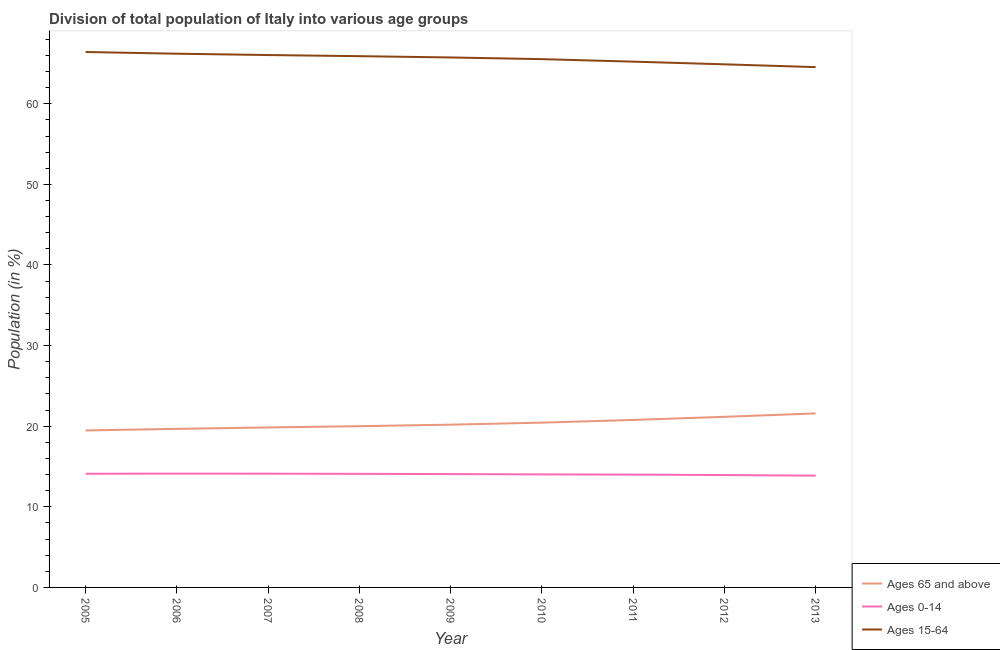How many different coloured lines are there?
Give a very brief answer. 3. Does the line corresponding to percentage of population within the age-group of 65 and above intersect with the line corresponding to percentage of population within the age-group 15-64?
Your answer should be very brief. No. Is the number of lines equal to the number of legend labels?
Keep it short and to the point. Yes. What is the percentage of population within the age-group 15-64 in 2009?
Keep it short and to the point. 65.75. Across all years, what is the maximum percentage of population within the age-group 0-14?
Your response must be concise. 14.12. Across all years, what is the minimum percentage of population within the age-group 15-64?
Offer a terse response. 64.55. What is the total percentage of population within the age-group of 65 and above in the graph?
Your answer should be very brief. 183.16. What is the difference between the percentage of population within the age-group 15-64 in 2005 and that in 2008?
Your response must be concise. 0.52. What is the difference between the percentage of population within the age-group 15-64 in 2013 and the percentage of population within the age-group 0-14 in 2009?
Provide a succinct answer. 50.49. What is the average percentage of population within the age-group 0-14 per year?
Ensure brevity in your answer.  14.03. In the year 2008, what is the difference between the percentage of population within the age-group of 65 and above and percentage of population within the age-group 0-14?
Ensure brevity in your answer.  5.92. In how many years, is the percentage of population within the age-group of 65 and above greater than 56 %?
Your response must be concise. 0. What is the ratio of the percentage of population within the age-group of 65 and above in 2007 to that in 2010?
Offer a very short reply. 0.97. Is the percentage of population within the age-group 15-64 in 2006 less than that in 2009?
Offer a very short reply. No. What is the difference between the highest and the second highest percentage of population within the age-group 15-64?
Your answer should be compact. 0.21. What is the difference between the highest and the lowest percentage of population within the age-group 0-14?
Your response must be concise. 0.25. In how many years, is the percentage of population within the age-group of 65 and above greater than the average percentage of population within the age-group of 65 and above taken over all years?
Give a very brief answer. 4. Is it the case that in every year, the sum of the percentage of population within the age-group of 65 and above and percentage of population within the age-group 0-14 is greater than the percentage of population within the age-group 15-64?
Your answer should be compact. No. Does the percentage of population within the age-group of 65 and above monotonically increase over the years?
Keep it short and to the point. Yes. How many lines are there?
Make the answer very short. 3. How many years are there in the graph?
Provide a short and direct response. 9. Are the values on the major ticks of Y-axis written in scientific E-notation?
Make the answer very short. No. How many legend labels are there?
Offer a very short reply. 3. How are the legend labels stacked?
Provide a short and direct response. Vertical. What is the title of the graph?
Make the answer very short. Division of total population of Italy into various age groups
. Does "Argument" appear as one of the legend labels in the graph?
Make the answer very short. No. What is the label or title of the X-axis?
Offer a very short reply. Year. What is the label or title of the Y-axis?
Keep it short and to the point. Population (in %). What is the Population (in %) in Ages 65 and above in 2005?
Offer a terse response. 19.47. What is the Population (in %) of Ages 0-14 in 2005?
Offer a very short reply. 14.11. What is the Population (in %) of Ages 15-64 in 2005?
Provide a short and direct response. 66.42. What is the Population (in %) in Ages 65 and above in 2006?
Make the answer very short. 19.67. What is the Population (in %) in Ages 0-14 in 2006?
Make the answer very short. 14.12. What is the Population (in %) in Ages 15-64 in 2006?
Your answer should be compact. 66.21. What is the Population (in %) in Ages 65 and above in 2007?
Give a very brief answer. 19.84. What is the Population (in %) of Ages 0-14 in 2007?
Provide a short and direct response. 14.11. What is the Population (in %) in Ages 15-64 in 2007?
Your answer should be very brief. 66.05. What is the Population (in %) of Ages 65 and above in 2008?
Your response must be concise. 20.01. What is the Population (in %) in Ages 0-14 in 2008?
Ensure brevity in your answer.  14.09. What is the Population (in %) in Ages 15-64 in 2008?
Provide a succinct answer. 65.91. What is the Population (in %) in Ages 65 and above in 2009?
Provide a succinct answer. 20.19. What is the Population (in %) in Ages 0-14 in 2009?
Offer a very short reply. 14.06. What is the Population (in %) in Ages 15-64 in 2009?
Offer a very short reply. 65.75. What is the Population (in %) in Ages 65 and above in 2010?
Offer a very short reply. 20.44. What is the Population (in %) in Ages 0-14 in 2010?
Your answer should be very brief. 14.02. What is the Population (in %) in Ages 15-64 in 2010?
Your response must be concise. 65.54. What is the Population (in %) in Ages 65 and above in 2011?
Your answer should be very brief. 20.78. What is the Population (in %) of Ages 0-14 in 2011?
Give a very brief answer. 14. What is the Population (in %) in Ages 15-64 in 2011?
Your answer should be very brief. 65.23. What is the Population (in %) in Ages 65 and above in 2012?
Your answer should be compact. 21.16. What is the Population (in %) of Ages 0-14 in 2012?
Your answer should be compact. 13.94. What is the Population (in %) of Ages 15-64 in 2012?
Offer a very short reply. 64.9. What is the Population (in %) in Ages 65 and above in 2013?
Provide a succinct answer. 21.59. What is the Population (in %) of Ages 0-14 in 2013?
Provide a succinct answer. 13.87. What is the Population (in %) of Ages 15-64 in 2013?
Give a very brief answer. 64.55. Across all years, what is the maximum Population (in %) of Ages 65 and above?
Your answer should be very brief. 21.59. Across all years, what is the maximum Population (in %) in Ages 0-14?
Offer a very short reply. 14.12. Across all years, what is the maximum Population (in %) of Ages 15-64?
Keep it short and to the point. 66.42. Across all years, what is the minimum Population (in %) of Ages 65 and above?
Make the answer very short. 19.47. Across all years, what is the minimum Population (in %) of Ages 0-14?
Offer a terse response. 13.87. Across all years, what is the minimum Population (in %) in Ages 15-64?
Offer a very short reply. 64.55. What is the total Population (in %) of Ages 65 and above in the graph?
Offer a terse response. 183.16. What is the total Population (in %) in Ages 0-14 in the graph?
Give a very brief answer. 126.3. What is the total Population (in %) of Ages 15-64 in the graph?
Provide a succinct answer. 590.54. What is the difference between the Population (in %) of Ages 65 and above in 2005 and that in 2006?
Offer a very short reply. -0.2. What is the difference between the Population (in %) of Ages 0-14 in 2005 and that in 2006?
Your response must be concise. -0.01. What is the difference between the Population (in %) in Ages 15-64 in 2005 and that in 2006?
Ensure brevity in your answer.  0.21. What is the difference between the Population (in %) of Ages 65 and above in 2005 and that in 2007?
Offer a terse response. -0.37. What is the difference between the Population (in %) of Ages 0-14 in 2005 and that in 2007?
Your answer should be compact. -0. What is the difference between the Population (in %) in Ages 15-64 in 2005 and that in 2007?
Provide a short and direct response. 0.38. What is the difference between the Population (in %) in Ages 65 and above in 2005 and that in 2008?
Offer a terse response. -0.53. What is the difference between the Population (in %) of Ages 0-14 in 2005 and that in 2008?
Provide a short and direct response. 0.02. What is the difference between the Population (in %) of Ages 15-64 in 2005 and that in 2008?
Ensure brevity in your answer.  0.52. What is the difference between the Population (in %) in Ages 65 and above in 2005 and that in 2009?
Give a very brief answer. -0.72. What is the difference between the Population (in %) of Ages 0-14 in 2005 and that in 2009?
Offer a terse response. 0.04. What is the difference between the Population (in %) in Ages 15-64 in 2005 and that in 2009?
Provide a succinct answer. 0.68. What is the difference between the Population (in %) in Ages 65 and above in 2005 and that in 2010?
Provide a succinct answer. -0.97. What is the difference between the Population (in %) in Ages 0-14 in 2005 and that in 2010?
Make the answer very short. 0.08. What is the difference between the Population (in %) of Ages 15-64 in 2005 and that in 2010?
Keep it short and to the point. 0.89. What is the difference between the Population (in %) of Ages 65 and above in 2005 and that in 2011?
Keep it short and to the point. -1.3. What is the difference between the Population (in %) in Ages 0-14 in 2005 and that in 2011?
Ensure brevity in your answer.  0.11. What is the difference between the Population (in %) of Ages 15-64 in 2005 and that in 2011?
Provide a short and direct response. 1.19. What is the difference between the Population (in %) in Ages 65 and above in 2005 and that in 2012?
Make the answer very short. -1.69. What is the difference between the Population (in %) in Ages 0-14 in 2005 and that in 2012?
Provide a short and direct response. 0.16. What is the difference between the Population (in %) in Ages 15-64 in 2005 and that in 2012?
Provide a short and direct response. 1.53. What is the difference between the Population (in %) of Ages 65 and above in 2005 and that in 2013?
Keep it short and to the point. -2.12. What is the difference between the Population (in %) in Ages 0-14 in 2005 and that in 2013?
Your answer should be very brief. 0.24. What is the difference between the Population (in %) of Ages 15-64 in 2005 and that in 2013?
Provide a succinct answer. 1.88. What is the difference between the Population (in %) in Ages 65 and above in 2006 and that in 2007?
Your answer should be compact. -0.17. What is the difference between the Population (in %) of Ages 0-14 in 2006 and that in 2007?
Your response must be concise. 0.01. What is the difference between the Population (in %) in Ages 15-64 in 2006 and that in 2007?
Keep it short and to the point. 0.17. What is the difference between the Population (in %) in Ages 65 and above in 2006 and that in 2008?
Make the answer very short. -0.33. What is the difference between the Population (in %) of Ages 0-14 in 2006 and that in 2008?
Your answer should be compact. 0.03. What is the difference between the Population (in %) of Ages 15-64 in 2006 and that in 2008?
Keep it short and to the point. 0.31. What is the difference between the Population (in %) of Ages 65 and above in 2006 and that in 2009?
Your response must be concise. -0.52. What is the difference between the Population (in %) of Ages 0-14 in 2006 and that in 2009?
Provide a short and direct response. 0.06. What is the difference between the Population (in %) in Ages 15-64 in 2006 and that in 2009?
Offer a terse response. 0.47. What is the difference between the Population (in %) in Ages 65 and above in 2006 and that in 2010?
Ensure brevity in your answer.  -0.77. What is the difference between the Population (in %) of Ages 0-14 in 2006 and that in 2010?
Provide a short and direct response. 0.09. What is the difference between the Population (in %) in Ages 15-64 in 2006 and that in 2010?
Your answer should be compact. 0.67. What is the difference between the Population (in %) in Ages 65 and above in 2006 and that in 2011?
Give a very brief answer. -1.1. What is the difference between the Population (in %) in Ages 0-14 in 2006 and that in 2011?
Your answer should be compact. 0.12. What is the difference between the Population (in %) in Ages 15-64 in 2006 and that in 2011?
Your answer should be very brief. 0.98. What is the difference between the Population (in %) in Ages 65 and above in 2006 and that in 2012?
Provide a succinct answer. -1.49. What is the difference between the Population (in %) in Ages 0-14 in 2006 and that in 2012?
Provide a short and direct response. 0.18. What is the difference between the Population (in %) in Ages 15-64 in 2006 and that in 2012?
Make the answer very short. 1.32. What is the difference between the Population (in %) of Ages 65 and above in 2006 and that in 2013?
Your response must be concise. -1.91. What is the difference between the Population (in %) in Ages 0-14 in 2006 and that in 2013?
Provide a short and direct response. 0.25. What is the difference between the Population (in %) of Ages 15-64 in 2006 and that in 2013?
Provide a succinct answer. 1.66. What is the difference between the Population (in %) in Ages 65 and above in 2007 and that in 2008?
Provide a succinct answer. -0.16. What is the difference between the Population (in %) in Ages 0-14 in 2007 and that in 2008?
Offer a very short reply. 0.02. What is the difference between the Population (in %) in Ages 15-64 in 2007 and that in 2008?
Your answer should be very brief. 0.14. What is the difference between the Population (in %) of Ages 65 and above in 2007 and that in 2009?
Provide a succinct answer. -0.35. What is the difference between the Population (in %) of Ages 0-14 in 2007 and that in 2009?
Provide a short and direct response. 0.05. What is the difference between the Population (in %) in Ages 15-64 in 2007 and that in 2009?
Offer a very short reply. 0.3. What is the difference between the Population (in %) in Ages 65 and above in 2007 and that in 2010?
Provide a short and direct response. -0.6. What is the difference between the Population (in %) in Ages 0-14 in 2007 and that in 2010?
Ensure brevity in your answer.  0.09. What is the difference between the Population (in %) in Ages 15-64 in 2007 and that in 2010?
Provide a succinct answer. 0.51. What is the difference between the Population (in %) of Ages 65 and above in 2007 and that in 2011?
Make the answer very short. -0.93. What is the difference between the Population (in %) of Ages 0-14 in 2007 and that in 2011?
Provide a succinct answer. 0.11. What is the difference between the Population (in %) in Ages 15-64 in 2007 and that in 2011?
Offer a terse response. 0.82. What is the difference between the Population (in %) of Ages 65 and above in 2007 and that in 2012?
Ensure brevity in your answer.  -1.32. What is the difference between the Population (in %) in Ages 0-14 in 2007 and that in 2012?
Make the answer very short. 0.17. What is the difference between the Population (in %) of Ages 15-64 in 2007 and that in 2012?
Offer a very short reply. 1.15. What is the difference between the Population (in %) of Ages 65 and above in 2007 and that in 2013?
Keep it short and to the point. -1.74. What is the difference between the Population (in %) of Ages 0-14 in 2007 and that in 2013?
Offer a very short reply. 0.24. What is the difference between the Population (in %) in Ages 15-64 in 2007 and that in 2013?
Ensure brevity in your answer.  1.5. What is the difference between the Population (in %) in Ages 65 and above in 2008 and that in 2009?
Provide a succinct answer. -0.19. What is the difference between the Population (in %) in Ages 0-14 in 2008 and that in 2009?
Ensure brevity in your answer.  0.03. What is the difference between the Population (in %) in Ages 15-64 in 2008 and that in 2009?
Your answer should be compact. 0.16. What is the difference between the Population (in %) of Ages 65 and above in 2008 and that in 2010?
Provide a succinct answer. -0.44. What is the difference between the Population (in %) of Ages 0-14 in 2008 and that in 2010?
Make the answer very short. 0.07. What is the difference between the Population (in %) of Ages 15-64 in 2008 and that in 2010?
Your answer should be compact. 0.37. What is the difference between the Population (in %) in Ages 65 and above in 2008 and that in 2011?
Provide a short and direct response. -0.77. What is the difference between the Population (in %) in Ages 0-14 in 2008 and that in 2011?
Provide a short and direct response. 0.09. What is the difference between the Population (in %) of Ages 15-64 in 2008 and that in 2011?
Make the answer very short. 0.68. What is the difference between the Population (in %) of Ages 65 and above in 2008 and that in 2012?
Give a very brief answer. -1.16. What is the difference between the Population (in %) of Ages 0-14 in 2008 and that in 2012?
Provide a short and direct response. 0.15. What is the difference between the Population (in %) of Ages 15-64 in 2008 and that in 2012?
Provide a short and direct response. 1.01. What is the difference between the Population (in %) of Ages 65 and above in 2008 and that in 2013?
Your response must be concise. -1.58. What is the difference between the Population (in %) of Ages 0-14 in 2008 and that in 2013?
Make the answer very short. 0.22. What is the difference between the Population (in %) in Ages 15-64 in 2008 and that in 2013?
Your answer should be very brief. 1.36. What is the difference between the Population (in %) of Ages 65 and above in 2009 and that in 2010?
Your answer should be very brief. -0.25. What is the difference between the Population (in %) in Ages 0-14 in 2009 and that in 2010?
Your response must be concise. 0.04. What is the difference between the Population (in %) in Ages 15-64 in 2009 and that in 2010?
Your answer should be very brief. 0.21. What is the difference between the Population (in %) in Ages 65 and above in 2009 and that in 2011?
Provide a short and direct response. -0.58. What is the difference between the Population (in %) in Ages 0-14 in 2009 and that in 2011?
Keep it short and to the point. 0.07. What is the difference between the Population (in %) of Ages 15-64 in 2009 and that in 2011?
Your answer should be compact. 0.52. What is the difference between the Population (in %) in Ages 65 and above in 2009 and that in 2012?
Offer a terse response. -0.97. What is the difference between the Population (in %) in Ages 0-14 in 2009 and that in 2012?
Keep it short and to the point. 0.12. What is the difference between the Population (in %) of Ages 15-64 in 2009 and that in 2012?
Your answer should be compact. 0.85. What is the difference between the Population (in %) in Ages 65 and above in 2009 and that in 2013?
Your answer should be very brief. -1.39. What is the difference between the Population (in %) in Ages 0-14 in 2009 and that in 2013?
Offer a very short reply. 0.2. What is the difference between the Population (in %) of Ages 15-64 in 2009 and that in 2013?
Your answer should be very brief. 1.2. What is the difference between the Population (in %) in Ages 65 and above in 2010 and that in 2011?
Make the answer very short. -0.34. What is the difference between the Population (in %) in Ages 0-14 in 2010 and that in 2011?
Ensure brevity in your answer.  0.03. What is the difference between the Population (in %) of Ages 15-64 in 2010 and that in 2011?
Offer a terse response. 0.31. What is the difference between the Population (in %) in Ages 65 and above in 2010 and that in 2012?
Make the answer very short. -0.72. What is the difference between the Population (in %) in Ages 0-14 in 2010 and that in 2012?
Offer a terse response. 0.08. What is the difference between the Population (in %) of Ages 15-64 in 2010 and that in 2012?
Your response must be concise. 0.64. What is the difference between the Population (in %) of Ages 65 and above in 2010 and that in 2013?
Offer a very short reply. -1.15. What is the difference between the Population (in %) in Ages 0-14 in 2010 and that in 2013?
Offer a very short reply. 0.16. What is the difference between the Population (in %) of Ages 15-64 in 2010 and that in 2013?
Your answer should be compact. 0.99. What is the difference between the Population (in %) in Ages 65 and above in 2011 and that in 2012?
Your answer should be very brief. -0.39. What is the difference between the Population (in %) in Ages 0-14 in 2011 and that in 2012?
Your answer should be very brief. 0.06. What is the difference between the Population (in %) in Ages 15-64 in 2011 and that in 2012?
Your answer should be compact. 0.33. What is the difference between the Population (in %) of Ages 65 and above in 2011 and that in 2013?
Your response must be concise. -0.81. What is the difference between the Population (in %) in Ages 0-14 in 2011 and that in 2013?
Ensure brevity in your answer.  0.13. What is the difference between the Population (in %) in Ages 15-64 in 2011 and that in 2013?
Ensure brevity in your answer.  0.68. What is the difference between the Population (in %) of Ages 65 and above in 2012 and that in 2013?
Offer a very short reply. -0.42. What is the difference between the Population (in %) of Ages 0-14 in 2012 and that in 2013?
Provide a succinct answer. 0.07. What is the difference between the Population (in %) of Ages 15-64 in 2012 and that in 2013?
Give a very brief answer. 0.35. What is the difference between the Population (in %) of Ages 65 and above in 2005 and the Population (in %) of Ages 0-14 in 2006?
Your answer should be compact. 5.36. What is the difference between the Population (in %) in Ages 65 and above in 2005 and the Population (in %) in Ages 15-64 in 2006?
Provide a succinct answer. -46.74. What is the difference between the Population (in %) of Ages 0-14 in 2005 and the Population (in %) of Ages 15-64 in 2006?
Your answer should be compact. -52.11. What is the difference between the Population (in %) in Ages 65 and above in 2005 and the Population (in %) in Ages 0-14 in 2007?
Offer a terse response. 5.36. What is the difference between the Population (in %) of Ages 65 and above in 2005 and the Population (in %) of Ages 15-64 in 2007?
Provide a succinct answer. -46.57. What is the difference between the Population (in %) of Ages 0-14 in 2005 and the Population (in %) of Ages 15-64 in 2007?
Keep it short and to the point. -51.94. What is the difference between the Population (in %) in Ages 65 and above in 2005 and the Population (in %) in Ages 0-14 in 2008?
Ensure brevity in your answer.  5.38. What is the difference between the Population (in %) in Ages 65 and above in 2005 and the Population (in %) in Ages 15-64 in 2008?
Ensure brevity in your answer.  -46.43. What is the difference between the Population (in %) in Ages 0-14 in 2005 and the Population (in %) in Ages 15-64 in 2008?
Keep it short and to the point. -51.8. What is the difference between the Population (in %) in Ages 65 and above in 2005 and the Population (in %) in Ages 0-14 in 2009?
Provide a succinct answer. 5.41. What is the difference between the Population (in %) in Ages 65 and above in 2005 and the Population (in %) in Ages 15-64 in 2009?
Provide a short and direct response. -46.27. What is the difference between the Population (in %) in Ages 0-14 in 2005 and the Population (in %) in Ages 15-64 in 2009?
Your answer should be very brief. -51.64. What is the difference between the Population (in %) of Ages 65 and above in 2005 and the Population (in %) of Ages 0-14 in 2010?
Make the answer very short. 5.45. What is the difference between the Population (in %) in Ages 65 and above in 2005 and the Population (in %) in Ages 15-64 in 2010?
Provide a succinct answer. -46.06. What is the difference between the Population (in %) in Ages 0-14 in 2005 and the Population (in %) in Ages 15-64 in 2010?
Ensure brevity in your answer.  -51.43. What is the difference between the Population (in %) of Ages 65 and above in 2005 and the Population (in %) of Ages 0-14 in 2011?
Provide a short and direct response. 5.48. What is the difference between the Population (in %) of Ages 65 and above in 2005 and the Population (in %) of Ages 15-64 in 2011?
Provide a short and direct response. -45.75. What is the difference between the Population (in %) of Ages 0-14 in 2005 and the Population (in %) of Ages 15-64 in 2011?
Ensure brevity in your answer.  -51.12. What is the difference between the Population (in %) of Ages 65 and above in 2005 and the Population (in %) of Ages 0-14 in 2012?
Your answer should be compact. 5.53. What is the difference between the Population (in %) in Ages 65 and above in 2005 and the Population (in %) in Ages 15-64 in 2012?
Make the answer very short. -45.42. What is the difference between the Population (in %) of Ages 0-14 in 2005 and the Population (in %) of Ages 15-64 in 2012?
Give a very brief answer. -50.79. What is the difference between the Population (in %) of Ages 65 and above in 2005 and the Population (in %) of Ages 0-14 in 2013?
Provide a short and direct response. 5.61. What is the difference between the Population (in %) in Ages 65 and above in 2005 and the Population (in %) in Ages 15-64 in 2013?
Give a very brief answer. -45.07. What is the difference between the Population (in %) of Ages 0-14 in 2005 and the Population (in %) of Ages 15-64 in 2013?
Make the answer very short. -50.44. What is the difference between the Population (in %) in Ages 65 and above in 2006 and the Population (in %) in Ages 0-14 in 2007?
Your answer should be compact. 5.56. What is the difference between the Population (in %) of Ages 65 and above in 2006 and the Population (in %) of Ages 15-64 in 2007?
Make the answer very short. -46.37. What is the difference between the Population (in %) of Ages 0-14 in 2006 and the Population (in %) of Ages 15-64 in 2007?
Provide a succinct answer. -51.93. What is the difference between the Population (in %) of Ages 65 and above in 2006 and the Population (in %) of Ages 0-14 in 2008?
Ensure brevity in your answer.  5.58. What is the difference between the Population (in %) in Ages 65 and above in 2006 and the Population (in %) in Ages 15-64 in 2008?
Ensure brevity in your answer.  -46.23. What is the difference between the Population (in %) in Ages 0-14 in 2006 and the Population (in %) in Ages 15-64 in 2008?
Offer a very short reply. -51.79. What is the difference between the Population (in %) in Ages 65 and above in 2006 and the Population (in %) in Ages 0-14 in 2009?
Offer a very short reply. 5.61. What is the difference between the Population (in %) of Ages 65 and above in 2006 and the Population (in %) of Ages 15-64 in 2009?
Ensure brevity in your answer.  -46.07. What is the difference between the Population (in %) of Ages 0-14 in 2006 and the Population (in %) of Ages 15-64 in 2009?
Keep it short and to the point. -51.63. What is the difference between the Population (in %) of Ages 65 and above in 2006 and the Population (in %) of Ages 0-14 in 2010?
Your answer should be compact. 5.65. What is the difference between the Population (in %) of Ages 65 and above in 2006 and the Population (in %) of Ages 15-64 in 2010?
Offer a very short reply. -45.86. What is the difference between the Population (in %) of Ages 0-14 in 2006 and the Population (in %) of Ages 15-64 in 2010?
Offer a terse response. -51.42. What is the difference between the Population (in %) in Ages 65 and above in 2006 and the Population (in %) in Ages 0-14 in 2011?
Provide a succinct answer. 5.68. What is the difference between the Population (in %) of Ages 65 and above in 2006 and the Population (in %) of Ages 15-64 in 2011?
Make the answer very short. -45.55. What is the difference between the Population (in %) in Ages 0-14 in 2006 and the Population (in %) in Ages 15-64 in 2011?
Provide a short and direct response. -51.11. What is the difference between the Population (in %) in Ages 65 and above in 2006 and the Population (in %) in Ages 0-14 in 2012?
Your response must be concise. 5.73. What is the difference between the Population (in %) in Ages 65 and above in 2006 and the Population (in %) in Ages 15-64 in 2012?
Your answer should be compact. -45.22. What is the difference between the Population (in %) in Ages 0-14 in 2006 and the Population (in %) in Ages 15-64 in 2012?
Make the answer very short. -50.78. What is the difference between the Population (in %) of Ages 65 and above in 2006 and the Population (in %) of Ages 0-14 in 2013?
Ensure brevity in your answer.  5.81. What is the difference between the Population (in %) of Ages 65 and above in 2006 and the Population (in %) of Ages 15-64 in 2013?
Offer a terse response. -44.87. What is the difference between the Population (in %) of Ages 0-14 in 2006 and the Population (in %) of Ages 15-64 in 2013?
Offer a terse response. -50.43. What is the difference between the Population (in %) in Ages 65 and above in 2007 and the Population (in %) in Ages 0-14 in 2008?
Ensure brevity in your answer.  5.76. What is the difference between the Population (in %) of Ages 65 and above in 2007 and the Population (in %) of Ages 15-64 in 2008?
Offer a terse response. -46.06. What is the difference between the Population (in %) in Ages 0-14 in 2007 and the Population (in %) in Ages 15-64 in 2008?
Your response must be concise. -51.8. What is the difference between the Population (in %) of Ages 65 and above in 2007 and the Population (in %) of Ages 0-14 in 2009?
Provide a succinct answer. 5.78. What is the difference between the Population (in %) in Ages 65 and above in 2007 and the Population (in %) in Ages 15-64 in 2009?
Provide a succinct answer. -45.9. What is the difference between the Population (in %) in Ages 0-14 in 2007 and the Population (in %) in Ages 15-64 in 2009?
Your response must be concise. -51.64. What is the difference between the Population (in %) of Ages 65 and above in 2007 and the Population (in %) of Ages 0-14 in 2010?
Provide a succinct answer. 5.82. What is the difference between the Population (in %) of Ages 65 and above in 2007 and the Population (in %) of Ages 15-64 in 2010?
Provide a succinct answer. -45.69. What is the difference between the Population (in %) of Ages 0-14 in 2007 and the Population (in %) of Ages 15-64 in 2010?
Offer a very short reply. -51.43. What is the difference between the Population (in %) in Ages 65 and above in 2007 and the Population (in %) in Ages 0-14 in 2011?
Make the answer very short. 5.85. What is the difference between the Population (in %) in Ages 65 and above in 2007 and the Population (in %) in Ages 15-64 in 2011?
Keep it short and to the point. -45.38. What is the difference between the Population (in %) in Ages 0-14 in 2007 and the Population (in %) in Ages 15-64 in 2011?
Offer a very short reply. -51.12. What is the difference between the Population (in %) of Ages 65 and above in 2007 and the Population (in %) of Ages 0-14 in 2012?
Make the answer very short. 5.9. What is the difference between the Population (in %) of Ages 65 and above in 2007 and the Population (in %) of Ages 15-64 in 2012?
Your answer should be compact. -45.05. What is the difference between the Population (in %) of Ages 0-14 in 2007 and the Population (in %) of Ages 15-64 in 2012?
Your response must be concise. -50.79. What is the difference between the Population (in %) in Ages 65 and above in 2007 and the Population (in %) in Ages 0-14 in 2013?
Keep it short and to the point. 5.98. What is the difference between the Population (in %) of Ages 65 and above in 2007 and the Population (in %) of Ages 15-64 in 2013?
Offer a terse response. -44.7. What is the difference between the Population (in %) of Ages 0-14 in 2007 and the Population (in %) of Ages 15-64 in 2013?
Your answer should be very brief. -50.44. What is the difference between the Population (in %) of Ages 65 and above in 2008 and the Population (in %) of Ages 0-14 in 2009?
Provide a succinct answer. 5.94. What is the difference between the Population (in %) of Ages 65 and above in 2008 and the Population (in %) of Ages 15-64 in 2009?
Keep it short and to the point. -45.74. What is the difference between the Population (in %) of Ages 0-14 in 2008 and the Population (in %) of Ages 15-64 in 2009?
Offer a very short reply. -51.66. What is the difference between the Population (in %) in Ages 65 and above in 2008 and the Population (in %) in Ages 0-14 in 2010?
Give a very brief answer. 5.98. What is the difference between the Population (in %) of Ages 65 and above in 2008 and the Population (in %) of Ages 15-64 in 2010?
Offer a very short reply. -45.53. What is the difference between the Population (in %) in Ages 0-14 in 2008 and the Population (in %) in Ages 15-64 in 2010?
Ensure brevity in your answer.  -51.45. What is the difference between the Population (in %) of Ages 65 and above in 2008 and the Population (in %) of Ages 0-14 in 2011?
Keep it short and to the point. 6.01. What is the difference between the Population (in %) of Ages 65 and above in 2008 and the Population (in %) of Ages 15-64 in 2011?
Make the answer very short. -45.22. What is the difference between the Population (in %) in Ages 0-14 in 2008 and the Population (in %) in Ages 15-64 in 2011?
Your answer should be very brief. -51.14. What is the difference between the Population (in %) in Ages 65 and above in 2008 and the Population (in %) in Ages 0-14 in 2012?
Your answer should be compact. 6.06. What is the difference between the Population (in %) of Ages 65 and above in 2008 and the Population (in %) of Ages 15-64 in 2012?
Your answer should be compact. -44.89. What is the difference between the Population (in %) in Ages 0-14 in 2008 and the Population (in %) in Ages 15-64 in 2012?
Your response must be concise. -50.81. What is the difference between the Population (in %) of Ages 65 and above in 2008 and the Population (in %) of Ages 0-14 in 2013?
Give a very brief answer. 6.14. What is the difference between the Population (in %) in Ages 65 and above in 2008 and the Population (in %) in Ages 15-64 in 2013?
Provide a short and direct response. -44.54. What is the difference between the Population (in %) in Ages 0-14 in 2008 and the Population (in %) in Ages 15-64 in 2013?
Your answer should be compact. -50.46. What is the difference between the Population (in %) in Ages 65 and above in 2009 and the Population (in %) in Ages 0-14 in 2010?
Offer a terse response. 6.17. What is the difference between the Population (in %) in Ages 65 and above in 2009 and the Population (in %) in Ages 15-64 in 2010?
Keep it short and to the point. -45.34. What is the difference between the Population (in %) in Ages 0-14 in 2009 and the Population (in %) in Ages 15-64 in 2010?
Offer a terse response. -51.48. What is the difference between the Population (in %) of Ages 65 and above in 2009 and the Population (in %) of Ages 0-14 in 2011?
Provide a short and direct response. 6.2. What is the difference between the Population (in %) of Ages 65 and above in 2009 and the Population (in %) of Ages 15-64 in 2011?
Your answer should be very brief. -45.03. What is the difference between the Population (in %) in Ages 0-14 in 2009 and the Population (in %) in Ages 15-64 in 2011?
Your answer should be very brief. -51.17. What is the difference between the Population (in %) of Ages 65 and above in 2009 and the Population (in %) of Ages 0-14 in 2012?
Offer a terse response. 6.25. What is the difference between the Population (in %) of Ages 65 and above in 2009 and the Population (in %) of Ages 15-64 in 2012?
Provide a succinct answer. -44.7. What is the difference between the Population (in %) in Ages 0-14 in 2009 and the Population (in %) in Ages 15-64 in 2012?
Provide a short and direct response. -50.84. What is the difference between the Population (in %) in Ages 65 and above in 2009 and the Population (in %) in Ages 0-14 in 2013?
Provide a succinct answer. 6.33. What is the difference between the Population (in %) of Ages 65 and above in 2009 and the Population (in %) of Ages 15-64 in 2013?
Provide a succinct answer. -44.35. What is the difference between the Population (in %) in Ages 0-14 in 2009 and the Population (in %) in Ages 15-64 in 2013?
Provide a succinct answer. -50.49. What is the difference between the Population (in %) in Ages 65 and above in 2010 and the Population (in %) in Ages 0-14 in 2011?
Make the answer very short. 6.45. What is the difference between the Population (in %) in Ages 65 and above in 2010 and the Population (in %) in Ages 15-64 in 2011?
Your response must be concise. -44.78. What is the difference between the Population (in %) in Ages 0-14 in 2010 and the Population (in %) in Ages 15-64 in 2011?
Ensure brevity in your answer.  -51.21. What is the difference between the Population (in %) of Ages 65 and above in 2010 and the Population (in %) of Ages 0-14 in 2012?
Ensure brevity in your answer.  6.5. What is the difference between the Population (in %) of Ages 65 and above in 2010 and the Population (in %) of Ages 15-64 in 2012?
Offer a very short reply. -44.45. What is the difference between the Population (in %) of Ages 0-14 in 2010 and the Population (in %) of Ages 15-64 in 2012?
Offer a terse response. -50.87. What is the difference between the Population (in %) in Ages 65 and above in 2010 and the Population (in %) in Ages 0-14 in 2013?
Your response must be concise. 6.58. What is the difference between the Population (in %) of Ages 65 and above in 2010 and the Population (in %) of Ages 15-64 in 2013?
Offer a very short reply. -44.1. What is the difference between the Population (in %) of Ages 0-14 in 2010 and the Population (in %) of Ages 15-64 in 2013?
Give a very brief answer. -50.53. What is the difference between the Population (in %) of Ages 65 and above in 2011 and the Population (in %) of Ages 0-14 in 2012?
Your answer should be very brief. 6.84. What is the difference between the Population (in %) of Ages 65 and above in 2011 and the Population (in %) of Ages 15-64 in 2012?
Make the answer very short. -44.12. What is the difference between the Population (in %) of Ages 0-14 in 2011 and the Population (in %) of Ages 15-64 in 2012?
Provide a succinct answer. -50.9. What is the difference between the Population (in %) of Ages 65 and above in 2011 and the Population (in %) of Ages 0-14 in 2013?
Your answer should be compact. 6.91. What is the difference between the Population (in %) of Ages 65 and above in 2011 and the Population (in %) of Ages 15-64 in 2013?
Your response must be concise. -43.77. What is the difference between the Population (in %) in Ages 0-14 in 2011 and the Population (in %) in Ages 15-64 in 2013?
Give a very brief answer. -50.55. What is the difference between the Population (in %) in Ages 65 and above in 2012 and the Population (in %) in Ages 0-14 in 2013?
Provide a short and direct response. 7.3. What is the difference between the Population (in %) of Ages 65 and above in 2012 and the Population (in %) of Ages 15-64 in 2013?
Offer a very short reply. -43.38. What is the difference between the Population (in %) in Ages 0-14 in 2012 and the Population (in %) in Ages 15-64 in 2013?
Provide a succinct answer. -50.61. What is the average Population (in %) of Ages 65 and above per year?
Your answer should be compact. 20.35. What is the average Population (in %) of Ages 0-14 per year?
Offer a very short reply. 14.03. What is the average Population (in %) in Ages 15-64 per year?
Ensure brevity in your answer.  65.62. In the year 2005, what is the difference between the Population (in %) in Ages 65 and above and Population (in %) in Ages 0-14?
Keep it short and to the point. 5.37. In the year 2005, what is the difference between the Population (in %) in Ages 65 and above and Population (in %) in Ages 15-64?
Offer a terse response. -46.95. In the year 2005, what is the difference between the Population (in %) in Ages 0-14 and Population (in %) in Ages 15-64?
Give a very brief answer. -52.32. In the year 2006, what is the difference between the Population (in %) in Ages 65 and above and Population (in %) in Ages 0-14?
Offer a very short reply. 5.56. In the year 2006, what is the difference between the Population (in %) in Ages 65 and above and Population (in %) in Ages 15-64?
Your answer should be very brief. -46.54. In the year 2006, what is the difference between the Population (in %) of Ages 0-14 and Population (in %) of Ages 15-64?
Your response must be concise. -52.1. In the year 2007, what is the difference between the Population (in %) of Ages 65 and above and Population (in %) of Ages 0-14?
Provide a succinct answer. 5.74. In the year 2007, what is the difference between the Population (in %) of Ages 65 and above and Population (in %) of Ages 15-64?
Keep it short and to the point. -46.2. In the year 2007, what is the difference between the Population (in %) of Ages 0-14 and Population (in %) of Ages 15-64?
Offer a very short reply. -51.94. In the year 2008, what is the difference between the Population (in %) of Ages 65 and above and Population (in %) of Ages 0-14?
Offer a very short reply. 5.92. In the year 2008, what is the difference between the Population (in %) in Ages 65 and above and Population (in %) in Ages 15-64?
Give a very brief answer. -45.9. In the year 2008, what is the difference between the Population (in %) of Ages 0-14 and Population (in %) of Ages 15-64?
Offer a terse response. -51.82. In the year 2009, what is the difference between the Population (in %) of Ages 65 and above and Population (in %) of Ages 0-14?
Make the answer very short. 6.13. In the year 2009, what is the difference between the Population (in %) of Ages 65 and above and Population (in %) of Ages 15-64?
Offer a very short reply. -45.55. In the year 2009, what is the difference between the Population (in %) in Ages 0-14 and Population (in %) in Ages 15-64?
Your answer should be very brief. -51.69. In the year 2010, what is the difference between the Population (in %) in Ages 65 and above and Population (in %) in Ages 0-14?
Ensure brevity in your answer.  6.42. In the year 2010, what is the difference between the Population (in %) of Ages 65 and above and Population (in %) of Ages 15-64?
Provide a short and direct response. -45.09. In the year 2010, what is the difference between the Population (in %) in Ages 0-14 and Population (in %) in Ages 15-64?
Give a very brief answer. -51.52. In the year 2011, what is the difference between the Population (in %) of Ages 65 and above and Population (in %) of Ages 0-14?
Provide a short and direct response. 6.78. In the year 2011, what is the difference between the Population (in %) of Ages 65 and above and Population (in %) of Ages 15-64?
Ensure brevity in your answer.  -44.45. In the year 2011, what is the difference between the Population (in %) in Ages 0-14 and Population (in %) in Ages 15-64?
Your answer should be very brief. -51.23. In the year 2012, what is the difference between the Population (in %) of Ages 65 and above and Population (in %) of Ages 0-14?
Your answer should be compact. 7.22. In the year 2012, what is the difference between the Population (in %) of Ages 65 and above and Population (in %) of Ages 15-64?
Give a very brief answer. -43.73. In the year 2012, what is the difference between the Population (in %) in Ages 0-14 and Population (in %) in Ages 15-64?
Give a very brief answer. -50.96. In the year 2013, what is the difference between the Population (in %) of Ages 65 and above and Population (in %) of Ages 0-14?
Offer a terse response. 7.72. In the year 2013, what is the difference between the Population (in %) of Ages 65 and above and Population (in %) of Ages 15-64?
Ensure brevity in your answer.  -42.96. In the year 2013, what is the difference between the Population (in %) in Ages 0-14 and Population (in %) in Ages 15-64?
Keep it short and to the point. -50.68. What is the ratio of the Population (in %) in Ages 0-14 in 2005 to that in 2006?
Ensure brevity in your answer.  1. What is the ratio of the Population (in %) in Ages 15-64 in 2005 to that in 2006?
Your answer should be very brief. 1. What is the ratio of the Population (in %) in Ages 65 and above in 2005 to that in 2007?
Offer a very short reply. 0.98. What is the ratio of the Population (in %) of Ages 0-14 in 2005 to that in 2007?
Offer a terse response. 1. What is the ratio of the Population (in %) in Ages 15-64 in 2005 to that in 2007?
Give a very brief answer. 1.01. What is the ratio of the Population (in %) of Ages 65 and above in 2005 to that in 2008?
Offer a very short reply. 0.97. What is the ratio of the Population (in %) of Ages 0-14 in 2005 to that in 2008?
Ensure brevity in your answer.  1. What is the ratio of the Population (in %) in Ages 15-64 in 2005 to that in 2008?
Offer a very short reply. 1.01. What is the ratio of the Population (in %) in Ages 15-64 in 2005 to that in 2009?
Your answer should be compact. 1.01. What is the ratio of the Population (in %) of Ages 65 and above in 2005 to that in 2010?
Your answer should be very brief. 0.95. What is the ratio of the Population (in %) in Ages 0-14 in 2005 to that in 2010?
Offer a very short reply. 1.01. What is the ratio of the Population (in %) in Ages 15-64 in 2005 to that in 2010?
Ensure brevity in your answer.  1.01. What is the ratio of the Population (in %) in Ages 65 and above in 2005 to that in 2011?
Ensure brevity in your answer.  0.94. What is the ratio of the Population (in %) of Ages 15-64 in 2005 to that in 2011?
Give a very brief answer. 1.02. What is the ratio of the Population (in %) in Ages 65 and above in 2005 to that in 2012?
Offer a very short reply. 0.92. What is the ratio of the Population (in %) of Ages 0-14 in 2005 to that in 2012?
Keep it short and to the point. 1.01. What is the ratio of the Population (in %) in Ages 15-64 in 2005 to that in 2012?
Provide a short and direct response. 1.02. What is the ratio of the Population (in %) of Ages 65 and above in 2005 to that in 2013?
Your answer should be very brief. 0.9. What is the ratio of the Population (in %) in Ages 0-14 in 2005 to that in 2013?
Offer a terse response. 1.02. What is the ratio of the Population (in %) of Ages 15-64 in 2005 to that in 2013?
Offer a terse response. 1.03. What is the ratio of the Population (in %) of Ages 0-14 in 2006 to that in 2007?
Make the answer very short. 1. What is the ratio of the Population (in %) in Ages 65 and above in 2006 to that in 2008?
Offer a terse response. 0.98. What is the ratio of the Population (in %) of Ages 0-14 in 2006 to that in 2008?
Provide a short and direct response. 1. What is the ratio of the Population (in %) in Ages 65 and above in 2006 to that in 2009?
Keep it short and to the point. 0.97. What is the ratio of the Population (in %) of Ages 0-14 in 2006 to that in 2009?
Ensure brevity in your answer.  1. What is the ratio of the Population (in %) of Ages 15-64 in 2006 to that in 2009?
Make the answer very short. 1.01. What is the ratio of the Population (in %) of Ages 65 and above in 2006 to that in 2010?
Ensure brevity in your answer.  0.96. What is the ratio of the Population (in %) of Ages 0-14 in 2006 to that in 2010?
Keep it short and to the point. 1.01. What is the ratio of the Population (in %) in Ages 15-64 in 2006 to that in 2010?
Give a very brief answer. 1.01. What is the ratio of the Population (in %) in Ages 65 and above in 2006 to that in 2011?
Ensure brevity in your answer.  0.95. What is the ratio of the Population (in %) in Ages 0-14 in 2006 to that in 2011?
Keep it short and to the point. 1.01. What is the ratio of the Population (in %) of Ages 15-64 in 2006 to that in 2011?
Provide a short and direct response. 1.02. What is the ratio of the Population (in %) of Ages 65 and above in 2006 to that in 2012?
Provide a short and direct response. 0.93. What is the ratio of the Population (in %) of Ages 0-14 in 2006 to that in 2012?
Provide a short and direct response. 1.01. What is the ratio of the Population (in %) in Ages 15-64 in 2006 to that in 2012?
Make the answer very short. 1.02. What is the ratio of the Population (in %) of Ages 65 and above in 2006 to that in 2013?
Provide a short and direct response. 0.91. What is the ratio of the Population (in %) in Ages 0-14 in 2006 to that in 2013?
Offer a very short reply. 1.02. What is the ratio of the Population (in %) in Ages 15-64 in 2006 to that in 2013?
Provide a succinct answer. 1.03. What is the ratio of the Population (in %) in Ages 0-14 in 2007 to that in 2008?
Make the answer very short. 1. What is the ratio of the Population (in %) of Ages 65 and above in 2007 to that in 2009?
Give a very brief answer. 0.98. What is the ratio of the Population (in %) in Ages 65 and above in 2007 to that in 2010?
Your response must be concise. 0.97. What is the ratio of the Population (in %) in Ages 15-64 in 2007 to that in 2010?
Your answer should be compact. 1.01. What is the ratio of the Population (in %) of Ages 65 and above in 2007 to that in 2011?
Provide a short and direct response. 0.96. What is the ratio of the Population (in %) of Ages 0-14 in 2007 to that in 2011?
Ensure brevity in your answer.  1.01. What is the ratio of the Population (in %) in Ages 15-64 in 2007 to that in 2011?
Offer a very short reply. 1.01. What is the ratio of the Population (in %) in Ages 65 and above in 2007 to that in 2012?
Offer a very short reply. 0.94. What is the ratio of the Population (in %) in Ages 0-14 in 2007 to that in 2012?
Provide a short and direct response. 1.01. What is the ratio of the Population (in %) of Ages 15-64 in 2007 to that in 2012?
Offer a terse response. 1.02. What is the ratio of the Population (in %) of Ages 65 and above in 2007 to that in 2013?
Keep it short and to the point. 0.92. What is the ratio of the Population (in %) in Ages 0-14 in 2007 to that in 2013?
Your response must be concise. 1.02. What is the ratio of the Population (in %) in Ages 15-64 in 2007 to that in 2013?
Give a very brief answer. 1.02. What is the ratio of the Population (in %) of Ages 65 and above in 2008 to that in 2009?
Your answer should be compact. 0.99. What is the ratio of the Population (in %) of Ages 0-14 in 2008 to that in 2009?
Your answer should be very brief. 1. What is the ratio of the Population (in %) in Ages 15-64 in 2008 to that in 2009?
Offer a terse response. 1. What is the ratio of the Population (in %) in Ages 65 and above in 2008 to that in 2010?
Keep it short and to the point. 0.98. What is the ratio of the Population (in %) in Ages 15-64 in 2008 to that in 2010?
Your answer should be compact. 1.01. What is the ratio of the Population (in %) of Ages 65 and above in 2008 to that in 2011?
Make the answer very short. 0.96. What is the ratio of the Population (in %) in Ages 0-14 in 2008 to that in 2011?
Your answer should be compact. 1.01. What is the ratio of the Population (in %) in Ages 15-64 in 2008 to that in 2011?
Offer a very short reply. 1.01. What is the ratio of the Population (in %) of Ages 65 and above in 2008 to that in 2012?
Provide a succinct answer. 0.95. What is the ratio of the Population (in %) of Ages 0-14 in 2008 to that in 2012?
Ensure brevity in your answer.  1.01. What is the ratio of the Population (in %) of Ages 15-64 in 2008 to that in 2012?
Your response must be concise. 1.02. What is the ratio of the Population (in %) of Ages 65 and above in 2008 to that in 2013?
Make the answer very short. 0.93. What is the ratio of the Population (in %) of Ages 0-14 in 2008 to that in 2013?
Provide a short and direct response. 1.02. What is the ratio of the Population (in %) of Ages 15-64 in 2008 to that in 2013?
Your response must be concise. 1.02. What is the ratio of the Population (in %) in Ages 65 and above in 2009 to that in 2010?
Provide a succinct answer. 0.99. What is the ratio of the Population (in %) of Ages 65 and above in 2009 to that in 2011?
Your answer should be very brief. 0.97. What is the ratio of the Population (in %) of Ages 0-14 in 2009 to that in 2011?
Your response must be concise. 1. What is the ratio of the Population (in %) of Ages 65 and above in 2009 to that in 2012?
Your answer should be very brief. 0.95. What is the ratio of the Population (in %) of Ages 0-14 in 2009 to that in 2012?
Provide a succinct answer. 1.01. What is the ratio of the Population (in %) of Ages 15-64 in 2009 to that in 2012?
Your answer should be compact. 1.01. What is the ratio of the Population (in %) in Ages 65 and above in 2009 to that in 2013?
Your answer should be very brief. 0.94. What is the ratio of the Population (in %) in Ages 0-14 in 2009 to that in 2013?
Make the answer very short. 1.01. What is the ratio of the Population (in %) of Ages 15-64 in 2009 to that in 2013?
Ensure brevity in your answer.  1.02. What is the ratio of the Population (in %) of Ages 65 and above in 2010 to that in 2011?
Offer a terse response. 0.98. What is the ratio of the Population (in %) of Ages 0-14 in 2010 to that in 2011?
Your response must be concise. 1. What is the ratio of the Population (in %) of Ages 15-64 in 2010 to that in 2011?
Provide a short and direct response. 1. What is the ratio of the Population (in %) in Ages 65 and above in 2010 to that in 2012?
Provide a short and direct response. 0.97. What is the ratio of the Population (in %) in Ages 15-64 in 2010 to that in 2012?
Make the answer very short. 1.01. What is the ratio of the Population (in %) of Ages 65 and above in 2010 to that in 2013?
Provide a succinct answer. 0.95. What is the ratio of the Population (in %) of Ages 0-14 in 2010 to that in 2013?
Provide a succinct answer. 1.01. What is the ratio of the Population (in %) of Ages 15-64 in 2010 to that in 2013?
Provide a succinct answer. 1.02. What is the ratio of the Population (in %) of Ages 65 and above in 2011 to that in 2012?
Offer a very short reply. 0.98. What is the ratio of the Population (in %) in Ages 0-14 in 2011 to that in 2012?
Provide a short and direct response. 1. What is the ratio of the Population (in %) in Ages 15-64 in 2011 to that in 2012?
Your response must be concise. 1.01. What is the ratio of the Population (in %) of Ages 65 and above in 2011 to that in 2013?
Ensure brevity in your answer.  0.96. What is the ratio of the Population (in %) of Ages 0-14 in 2011 to that in 2013?
Keep it short and to the point. 1.01. What is the ratio of the Population (in %) in Ages 15-64 in 2011 to that in 2013?
Offer a very short reply. 1.01. What is the ratio of the Population (in %) of Ages 65 and above in 2012 to that in 2013?
Offer a terse response. 0.98. What is the ratio of the Population (in %) of Ages 0-14 in 2012 to that in 2013?
Make the answer very short. 1.01. What is the ratio of the Population (in %) of Ages 15-64 in 2012 to that in 2013?
Offer a very short reply. 1.01. What is the difference between the highest and the second highest Population (in %) in Ages 65 and above?
Your response must be concise. 0.42. What is the difference between the highest and the second highest Population (in %) of Ages 0-14?
Offer a terse response. 0.01. What is the difference between the highest and the second highest Population (in %) in Ages 15-64?
Offer a very short reply. 0.21. What is the difference between the highest and the lowest Population (in %) in Ages 65 and above?
Offer a very short reply. 2.12. What is the difference between the highest and the lowest Population (in %) of Ages 0-14?
Your response must be concise. 0.25. What is the difference between the highest and the lowest Population (in %) in Ages 15-64?
Make the answer very short. 1.88. 